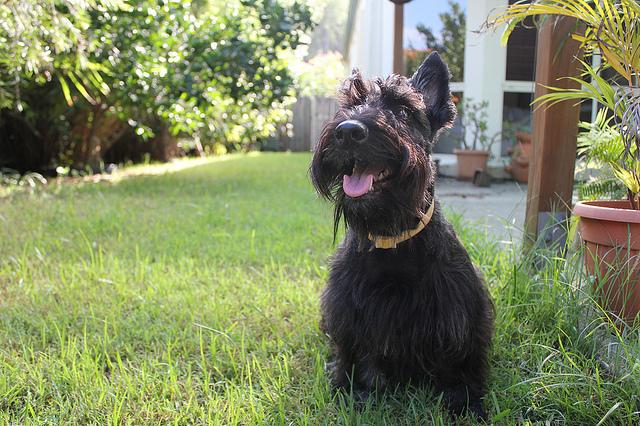Does the grass need cutting?
Concise answer only. Yes. What type of dog is this?
Short answer required. Terrier. Does this dog have a collar?
Write a very short answer. Yes. 